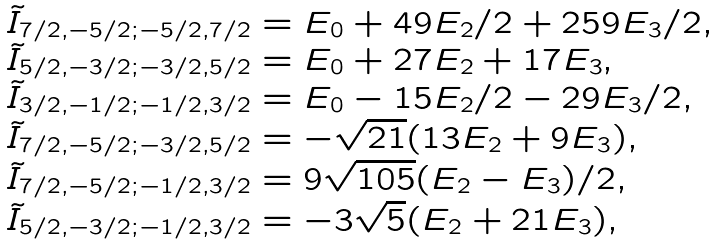<formula> <loc_0><loc_0><loc_500><loc_500>\begin{array} { l } { \tilde { I } } _ { 7 / 2 , - 5 / 2 ; - 5 / 2 , 7 / 2 } = E _ { 0 } + 4 9 E _ { 2 } / 2 + 2 5 9 E _ { 3 } / 2 , \\ { \tilde { I } } _ { 5 / 2 , - 3 / 2 ; - 3 / 2 , 5 / 2 } = E _ { 0 } + 2 7 E _ { 2 } + 1 7 E _ { 3 } , \\ { \tilde { I } } _ { 3 / 2 , - 1 / 2 ; - 1 / 2 , 3 / 2 } = E _ { 0 } - 1 5 E _ { 2 } / 2 - 2 9 E _ { 3 } / 2 , \\ { \tilde { I } } _ { 7 / 2 , - 5 / 2 ; - 3 / 2 , 5 / 2 } = - \sqrt { 2 1 } ( 1 3 E _ { 2 } + 9 E _ { 3 } ) , \\ { \tilde { I } } _ { 7 / 2 , - 5 / 2 ; - 1 / 2 , 3 / 2 } = 9 \sqrt { 1 0 5 } ( E _ { 2 } - E _ { 3 } ) / 2 , \\ { \tilde { I } } _ { 5 / 2 , - 3 / 2 ; - 1 / 2 , 3 / 2 } = - 3 \sqrt { 5 } ( E _ { 2 } + 2 1 E _ { 3 } ) , \end{array}</formula> 